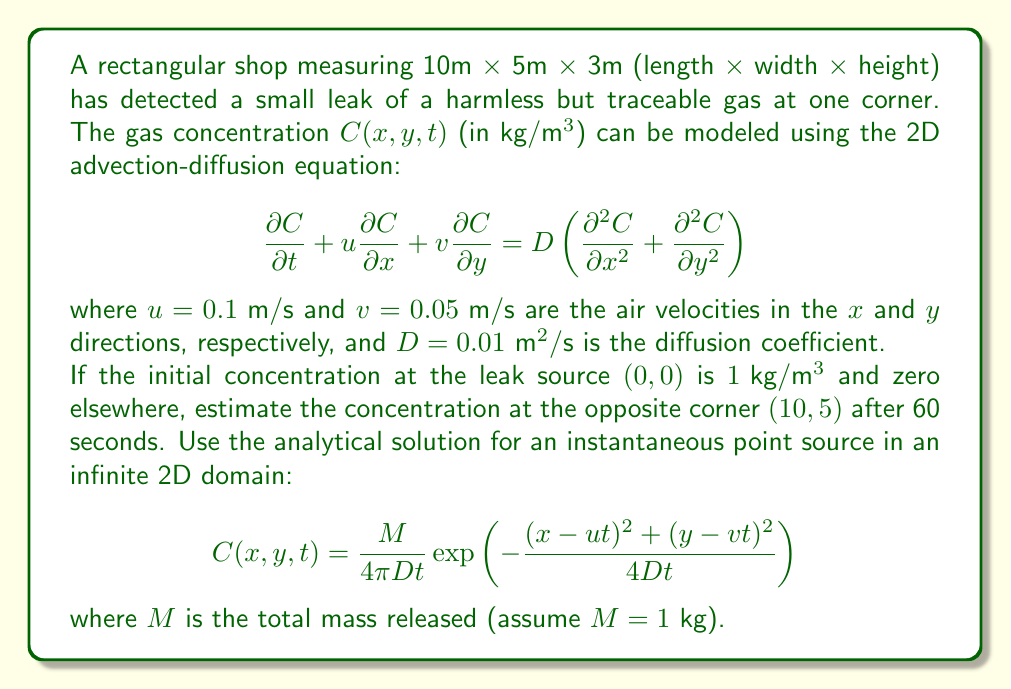What is the answer to this math problem? To solve this problem, we'll follow these steps:

1) First, we need to substitute the given values into the analytical solution:
   - $M = 1 \text{ kg}$
   - $D = 0.01 \text{ m}^2/\text{s}$
   - $t = 60 \text{ s}$
   - $u = 0.1 \text{ m/s}$
   - $v = 0.05 \text{ m/s}$
   - $x = 10 \text{ m}$
   - $y = 5 \text{ m}$

2) Let's start with the term outside the exponential:

   $$\frac{M}{4\pi Dt} = \frac{1}{4\pi(0.01)(60)} = \frac{1}{7.54} \approx 0.133$$

3) Now, let's calculate the terms inside the exponential:
   
   $(x-ut)^2 = (10 - 0.1 \cdot 60)^2 = 4^2 = 16$
   
   $(y-vt)^2 = (5 - 0.05 \cdot 60)^2 = 2^2 = 4$

4) The denominator in the exponential is:

   $4Dt = 4(0.01)(60) = 2.4$

5) Now we can calculate the exponential term:

   $$\exp\left(-\frac{16 + 4}{2.4}\right) = \exp\left(-\frac{20}{2.4}\right) = \exp(-8.33) \approx 0.00024$$

6) Finally, we multiply the results from steps 2 and 5:

   $C(10,5,60) \approx 0.133 \cdot 0.00024 \approx 3.19 \times 10^{-5} \text{ kg}/\text{m}^3$

This gives us the estimated concentration at the opposite corner after 60 seconds.
Answer: $3.19 \times 10^{-5} \text{ kg}/\text{m}^3$ 